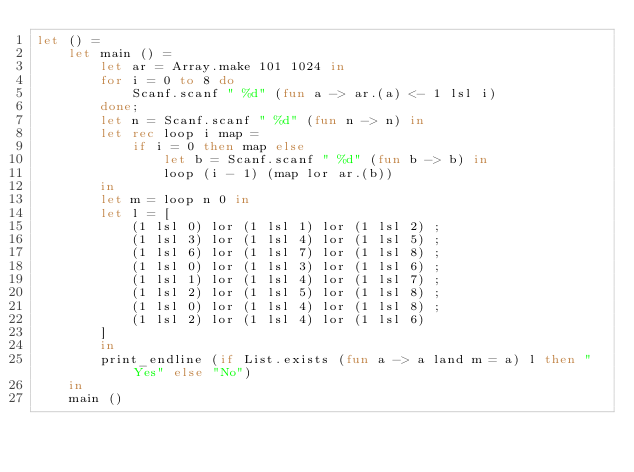<code> <loc_0><loc_0><loc_500><loc_500><_OCaml_>let () =
    let main () =
        let ar = Array.make 101 1024 in
        for i = 0 to 8 do
            Scanf.scanf " %d" (fun a -> ar.(a) <- 1 lsl i)
        done;
        let n = Scanf.scanf " %d" (fun n -> n) in
        let rec loop i map =
            if i = 0 then map else
                let b = Scanf.scanf " %d" (fun b -> b) in
                loop (i - 1) (map lor ar.(b))
        in
        let m = loop n 0 in
        let l = [
            (1 lsl 0) lor (1 lsl 1) lor (1 lsl 2) ;
            (1 lsl 3) lor (1 lsl 4) lor (1 lsl 5) ;
            (1 lsl 6) lor (1 lsl 7) lor (1 lsl 8) ;
            (1 lsl 0) lor (1 lsl 3) lor (1 lsl 6) ;
            (1 lsl 1) lor (1 lsl 4) lor (1 lsl 7) ;
            (1 lsl 2) lor (1 lsl 5) lor (1 lsl 8) ;
            (1 lsl 0) lor (1 lsl 4) lor (1 lsl 8) ;
            (1 lsl 2) lor (1 lsl 4) lor (1 lsl 6)
        ] 
        in
        print_endline (if List.exists (fun a -> a land m = a) l then "Yes" else "No")
    in
    main ()</code> 